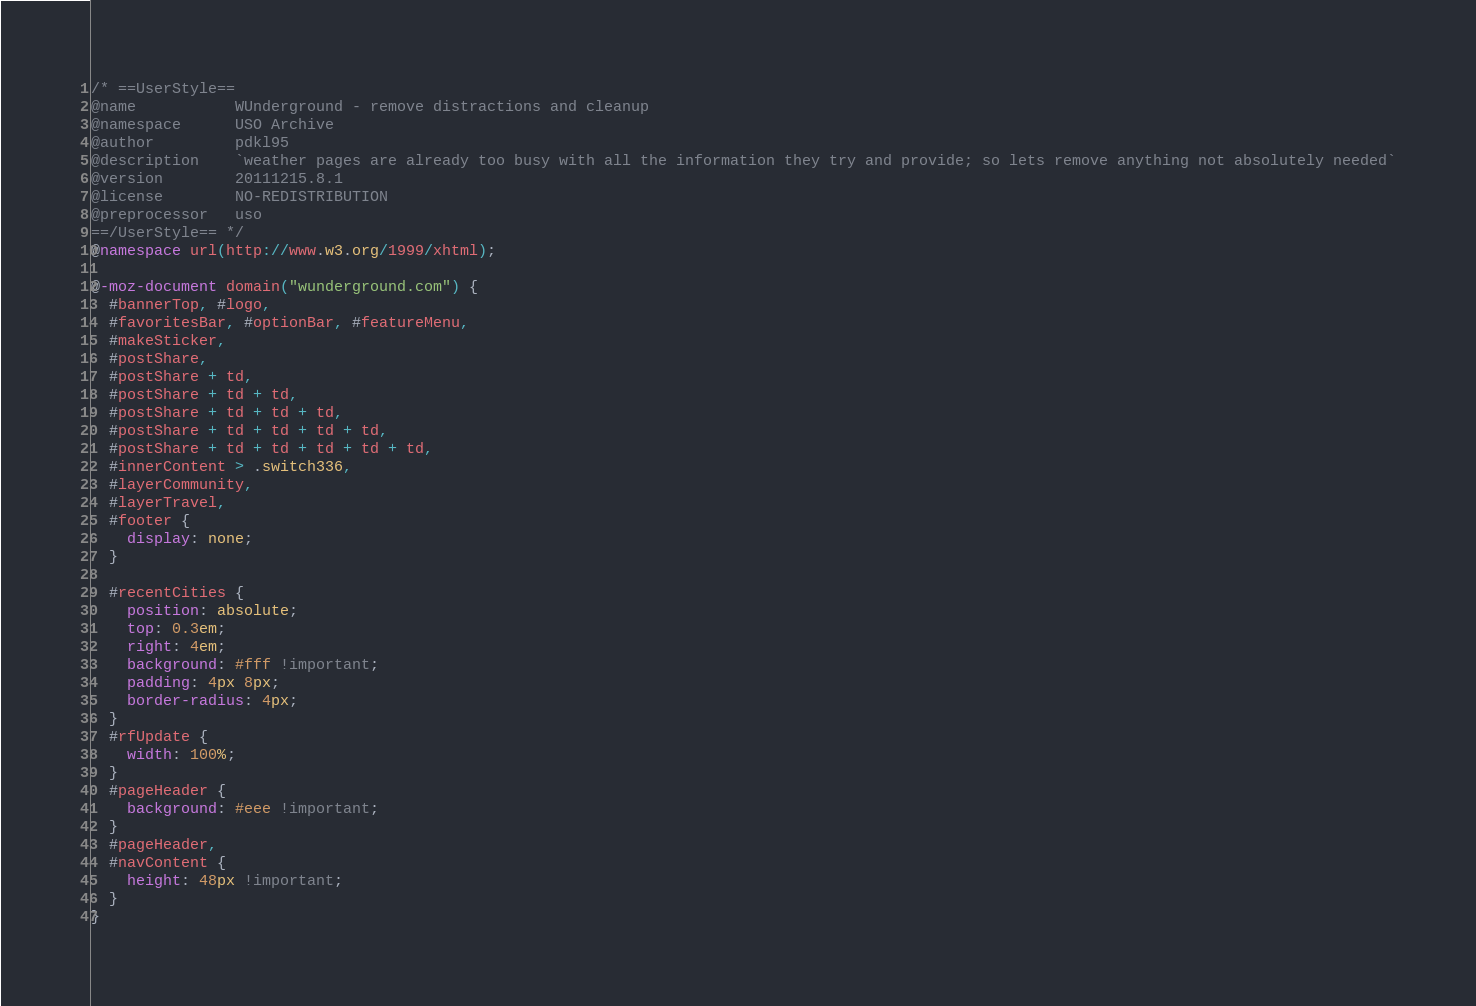<code> <loc_0><loc_0><loc_500><loc_500><_CSS_>/* ==UserStyle==
@name           WUnderground - remove distractions and cleanup
@namespace      USO Archive
@author         pdkl95
@description    `weather pages are already too busy with all the information they try and provide; so lets remove anything not absolutely needed`
@version        20111215.8.1
@license        NO-REDISTRIBUTION
@preprocessor   uso
==/UserStyle== */
@namespace url(http://www.w3.org/1999/xhtml);

@-moz-document domain("wunderground.com") {
  #bannerTop, #logo,
  #favoritesBar, #optionBar, #featureMenu,
  #makeSticker,
  #postShare,
  #postShare + td,
  #postShare + td + td,
  #postShare + td + td + td,
  #postShare + td + td + td + td,
  #postShare + td + td + td + td + td,
  #innerContent > .switch336,
  #layerCommunity,
  #layerTravel,
  #footer {
    display: none;
  }

  #recentCities {
    position: absolute;
    top: 0.3em;
    right: 4em;
    background: #fff !important;
    padding: 4px 8px;
    border-radius: 4px;
  }
  #rfUpdate {
    width: 100%;
  }
  #pageHeader {
    background: #eee !important;
  }
  #pageHeader,
  #navContent {
    height: 48px !important;
  }
}</code> 